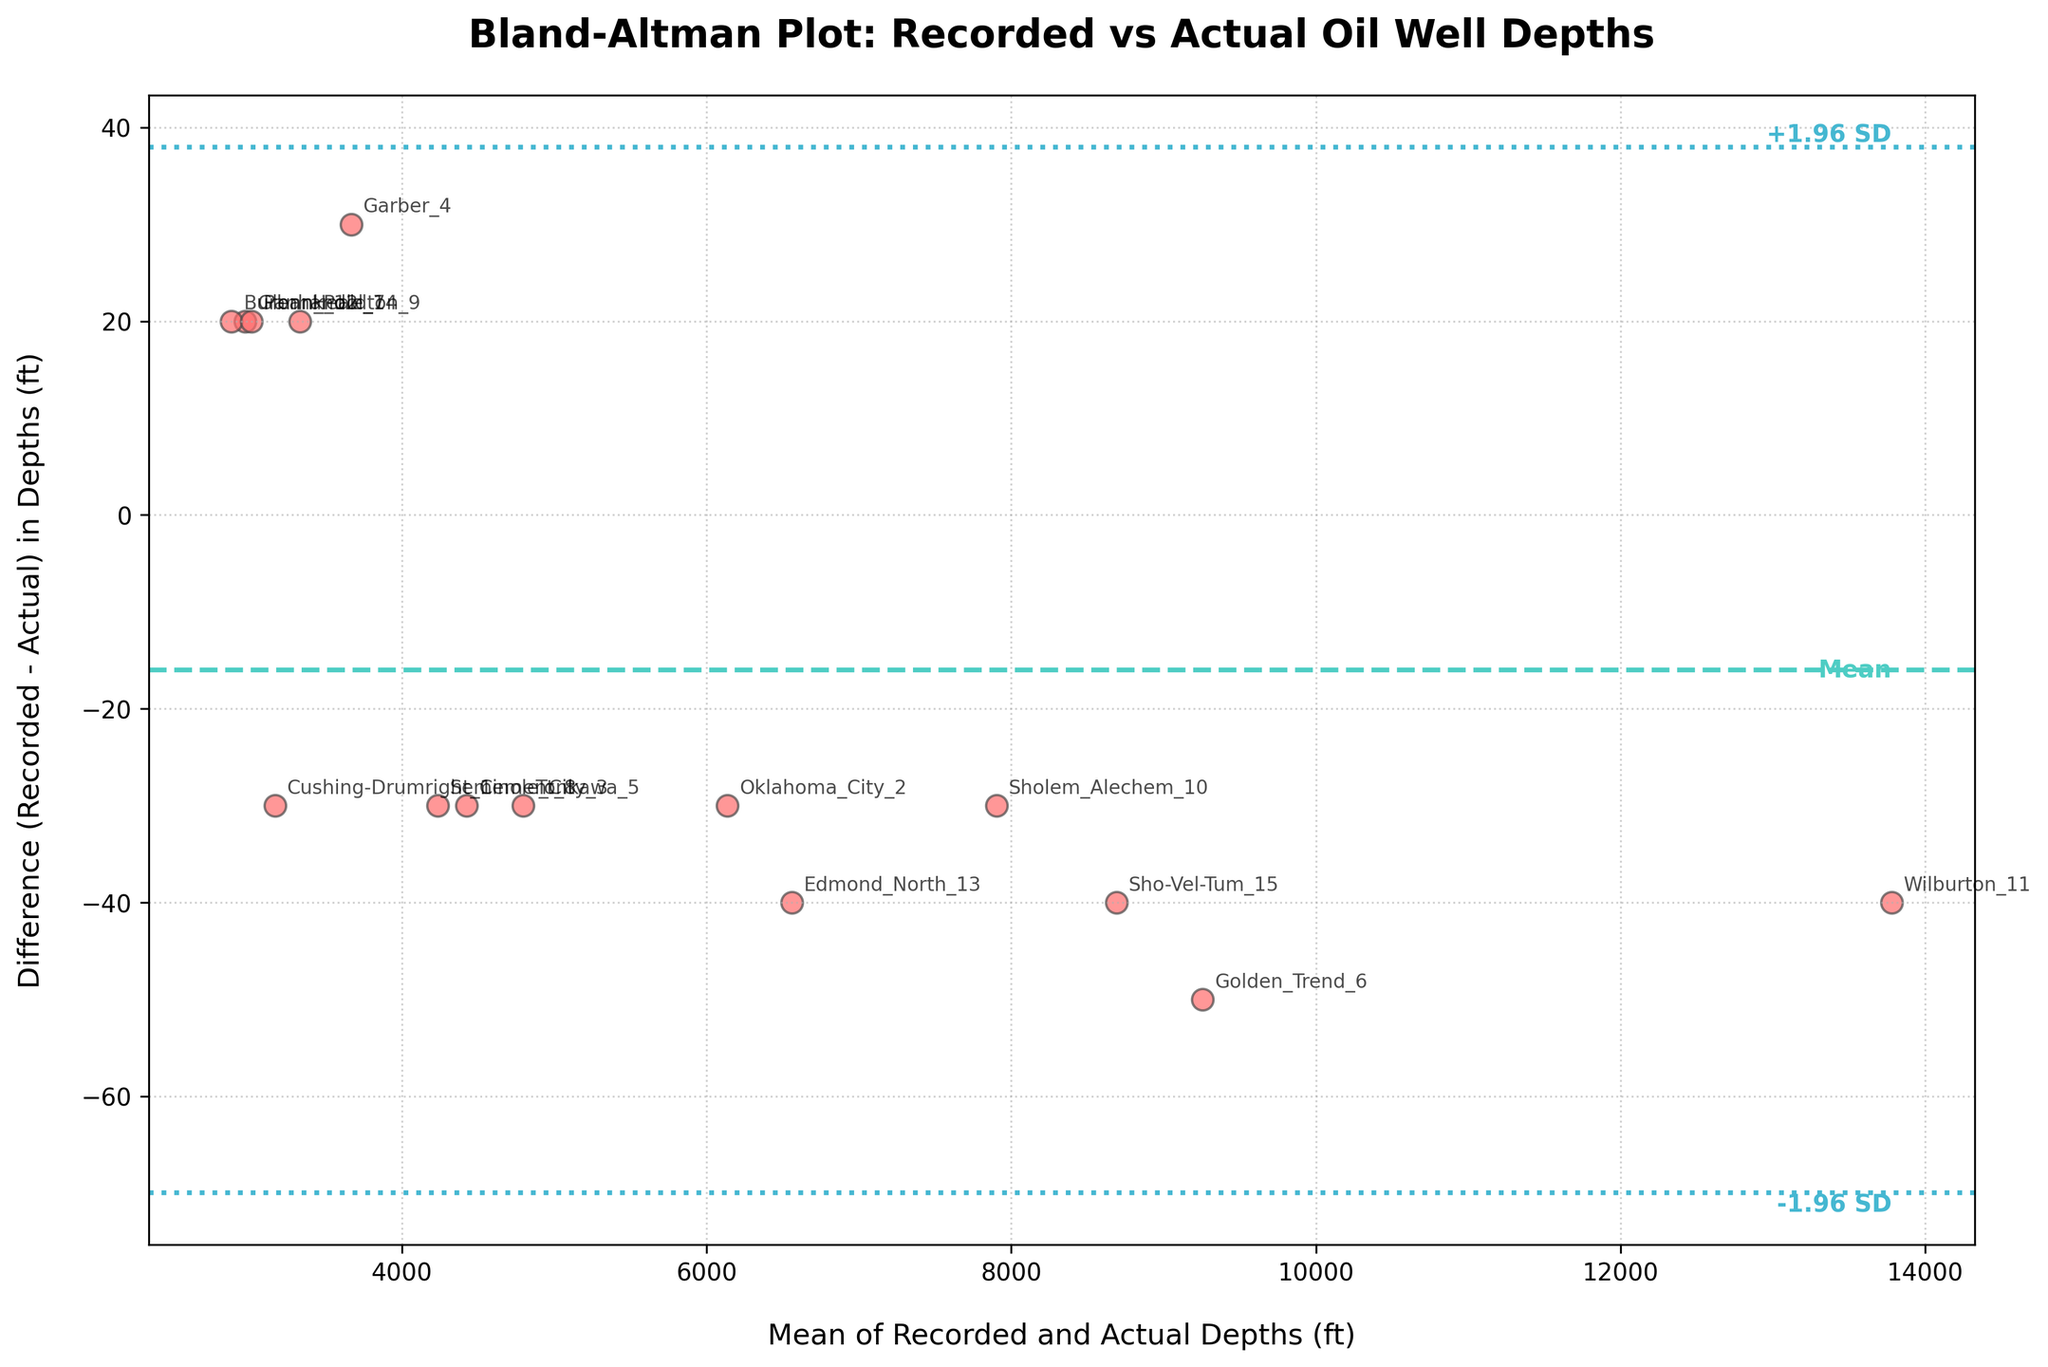What is the title of the plot? The title of the plot is typically found at the top and is a textual description summarizing the figure's content. Here, it reads: "Bland-Altman Plot: Recorded vs Actual Oil Well Depths".
Answer: Bland-Altman Plot: Recorded vs Actual Oil Well Depths How many data points are shown in the plot? Each data point represents an oil well, and there are annotations for each one. By counting these annotations, we can determine the number of data points.
Answer: 15 What do the x-axis and y-axis represent in the plot? The x-axis represents the mean of the Recorded and Actual Depths for each well, while the y-axis shows the difference between Recorded and Actual Depths (Recorded - Actual). These are clearly labeled in the plot.
Answer: Mean of Recorded and Actual Depths (x-axis) and Difference in Depths (y-axis) What is the mean difference in depths indicated by the dashed line? The mean difference is represented by the dashed line in the plot. It's labeled directly on the plot next to the line, indicating the mean difference value.
Answer: 7.33 ft Which oil well has the largest positive difference in depths? By looking at the data points and their annotations, we observe that the largest positive difference is the point that is highest on the y-axis. The annotation next to this point indicates the well name.
Answer: Wilburton_11 What is the approximate standard deviation of the differences in depth? The ±1.96 standard deviation lines (dotted lines) are provided. The space between the mean line and these lines can help calculate the standard deviation. As they are labeled on the plot, it shows +1.96 SD and -1.96 SD positions, allowing us to infer the value.
Answer: Approximately 32.51 ft Are there any wells for which the recorded depth is greater than the actual depth by more than 50 feet? This question requires finding points on the plot where the difference is more than 50 feet above the zero line. We need to visually scan for such differences above this threshold.
Answer: No Which wells have differences in depth close to zero? Points close to the zero line on the y-axis are those with minimal difference between recorded and actual depths. Identifying these points includes finding annotations near this line.
Answer: Glenn_Pool_7, Sholem_Alechem_10 What range captures most of the differences in depth according to the plot? The ±1.96 standard deviation lines help understand the range that captures most differences. These dotted lines typically encompass 95% of data points around the mean. By reading these off the plot, we can specify the range.
Answer: -57.69 ft to 72.35 ft 